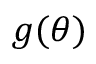<formula> <loc_0><loc_0><loc_500><loc_500>g ( \theta )</formula> 